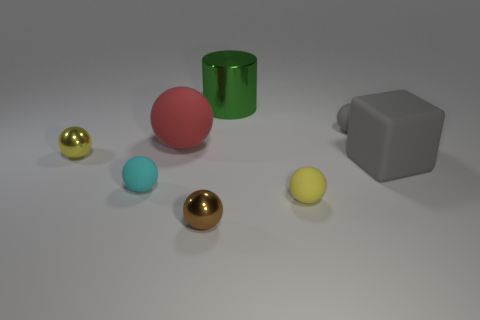Subtract all yellow metallic spheres. How many spheres are left? 5 Subtract all gray cubes. How many yellow spheres are left? 2 Subtract all yellow balls. How many balls are left? 4 Subtract 1 cubes. How many cubes are left? 0 Add 1 small yellow shiny objects. How many objects exist? 9 Subtract all balls. How many objects are left? 2 Add 7 red balls. How many red balls exist? 8 Subtract 0 cyan blocks. How many objects are left? 8 Subtract all gray cylinders. Subtract all brown blocks. How many cylinders are left? 1 Subtract all purple things. Subtract all tiny brown objects. How many objects are left? 7 